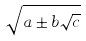Convert formula to latex. <formula><loc_0><loc_0><loc_500><loc_500>\sqrt { a \pm b \sqrt { c } }</formula> 